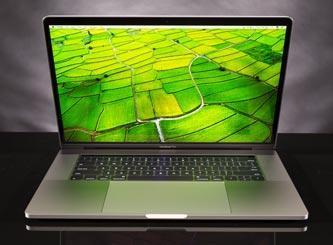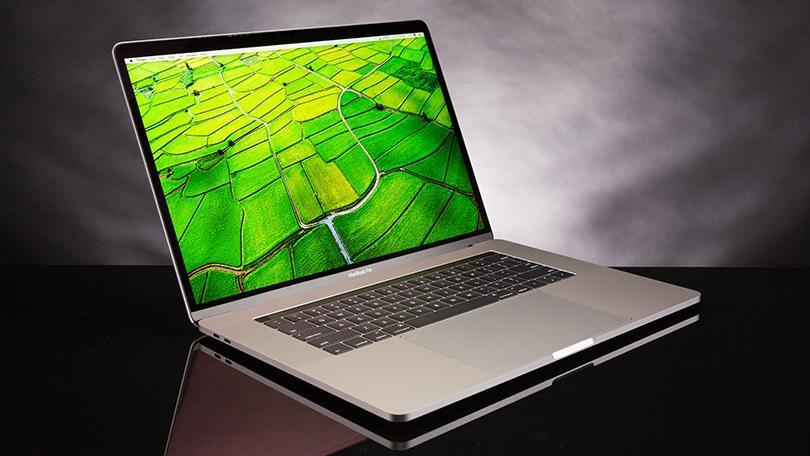The first image is the image on the left, the second image is the image on the right. Assess this claim about the two images: "Both computers are facing the left.". Correct or not? Answer yes or no. No. The first image is the image on the left, the second image is the image on the right. Analyze the images presented: Is the assertion "Both images show an open laptop tilted so the screen aims leftward." valid? Answer yes or no. No. 